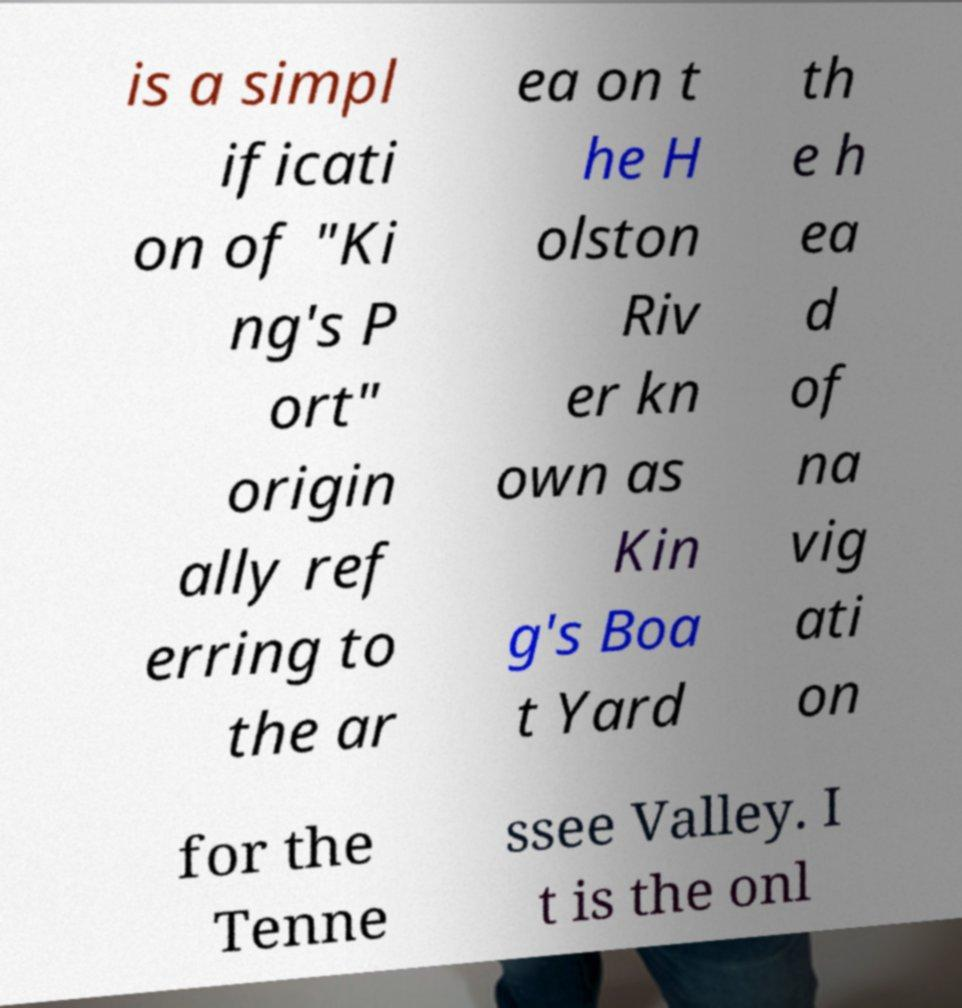Can you accurately transcribe the text from the provided image for me? is a simpl ificati on of "Ki ng's P ort" origin ally ref erring to the ar ea on t he H olston Riv er kn own as Kin g's Boa t Yard th e h ea d of na vig ati on for the Tenne ssee Valley. I t is the onl 